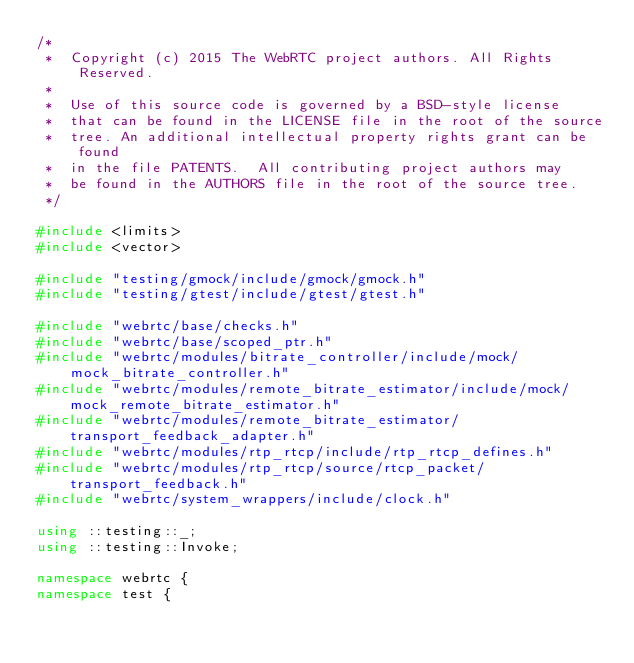Convert code to text. <code><loc_0><loc_0><loc_500><loc_500><_C++_>/*
 *  Copyright (c) 2015 The WebRTC project authors. All Rights Reserved.
 *
 *  Use of this source code is governed by a BSD-style license
 *  that can be found in the LICENSE file in the root of the source
 *  tree. An additional intellectual property rights grant can be found
 *  in the file PATENTS.  All contributing project authors may
 *  be found in the AUTHORS file in the root of the source tree.
 */

#include <limits>
#include <vector>

#include "testing/gmock/include/gmock/gmock.h"
#include "testing/gtest/include/gtest/gtest.h"

#include "webrtc/base/checks.h"
#include "webrtc/base/scoped_ptr.h"
#include "webrtc/modules/bitrate_controller/include/mock/mock_bitrate_controller.h"
#include "webrtc/modules/remote_bitrate_estimator/include/mock/mock_remote_bitrate_estimator.h"
#include "webrtc/modules/remote_bitrate_estimator/transport_feedback_adapter.h"
#include "webrtc/modules/rtp_rtcp/include/rtp_rtcp_defines.h"
#include "webrtc/modules/rtp_rtcp/source/rtcp_packet/transport_feedback.h"
#include "webrtc/system_wrappers/include/clock.h"

using ::testing::_;
using ::testing::Invoke;

namespace webrtc {
namespace test {
</code> 